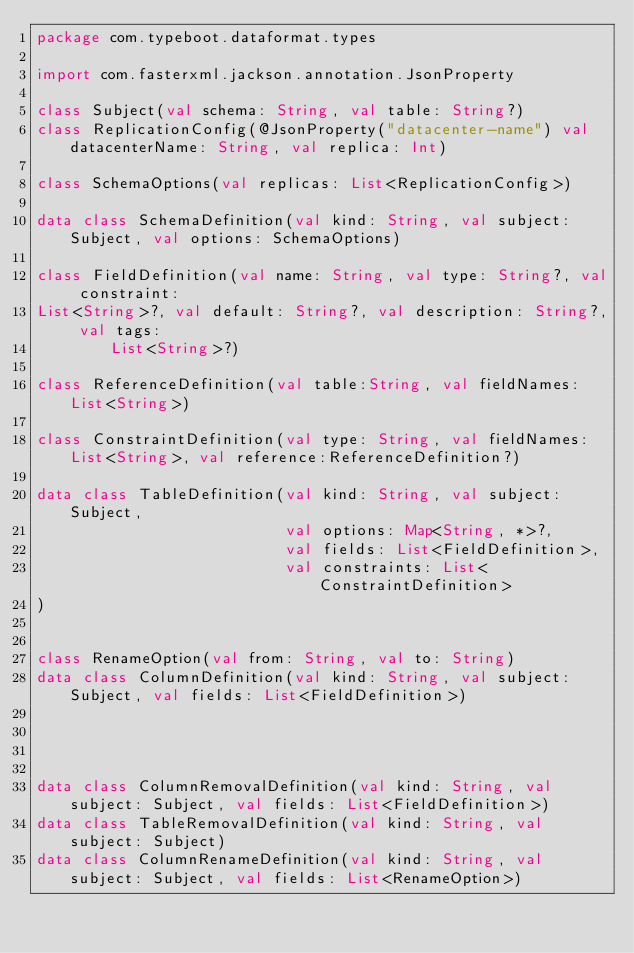<code> <loc_0><loc_0><loc_500><loc_500><_Kotlin_>package com.typeboot.dataformat.types

import com.fasterxml.jackson.annotation.JsonProperty

class Subject(val schema: String, val table: String?)
class ReplicationConfig(@JsonProperty("datacenter-name") val datacenterName: String, val replica: Int)

class SchemaOptions(val replicas: List<ReplicationConfig>)

data class SchemaDefinition(val kind: String, val subject: Subject, val options: SchemaOptions)

class FieldDefinition(val name: String, val type: String?, val constraint:
List<String>?, val default: String?, val description: String?, val tags:
        List<String>?)

class ReferenceDefinition(val table:String, val fieldNames:List<String>)

class ConstraintDefinition(val type: String, val fieldNames: List<String>, val reference:ReferenceDefinition?)

data class TableDefinition(val kind: String, val subject: Subject,
                           val options: Map<String, *>?,
                           val fields: List<FieldDefinition>,
                           val constraints: List<ConstraintDefinition>
)


class RenameOption(val from: String, val to: String)
data class ColumnDefinition(val kind: String, val subject: Subject, val fields: List<FieldDefinition>)




data class ColumnRemovalDefinition(val kind: String, val subject: Subject, val fields: List<FieldDefinition>)
data class TableRemovalDefinition(val kind: String, val subject: Subject)
data class ColumnRenameDefinition(val kind: String, val subject: Subject, val fields: List<RenameOption>)

</code> 